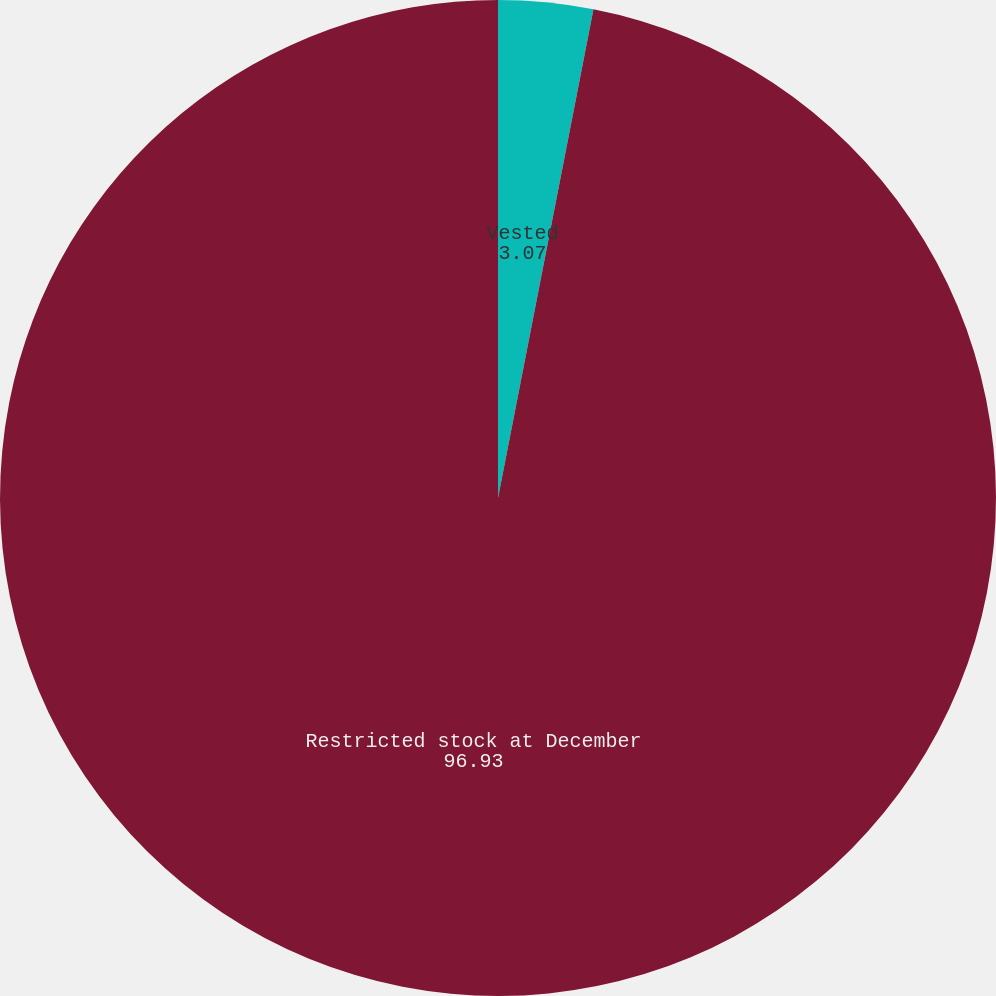Convert chart to OTSL. <chart><loc_0><loc_0><loc_500><loc_500><pie_chart><fcel>Vested<fcel>Restricted stock at December<nl><fcel>3.07%<fcel>96.93%<nl></chart> 